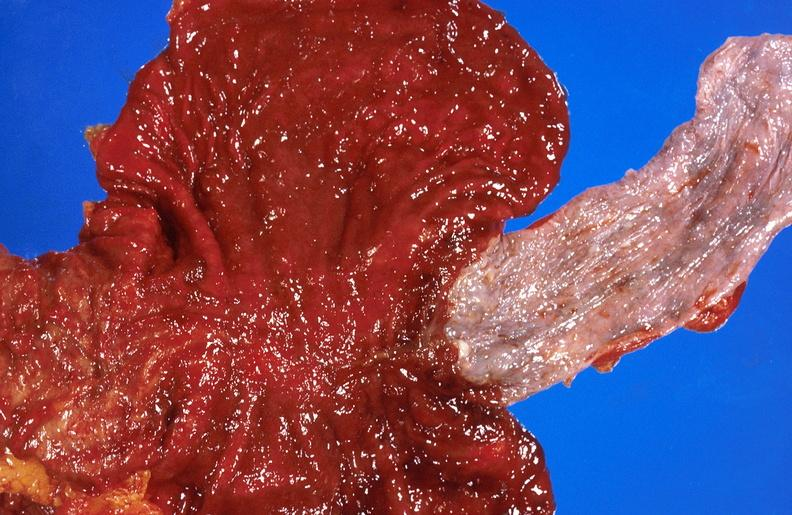what is present?
Answer the question using a single word or phrase. Liver 